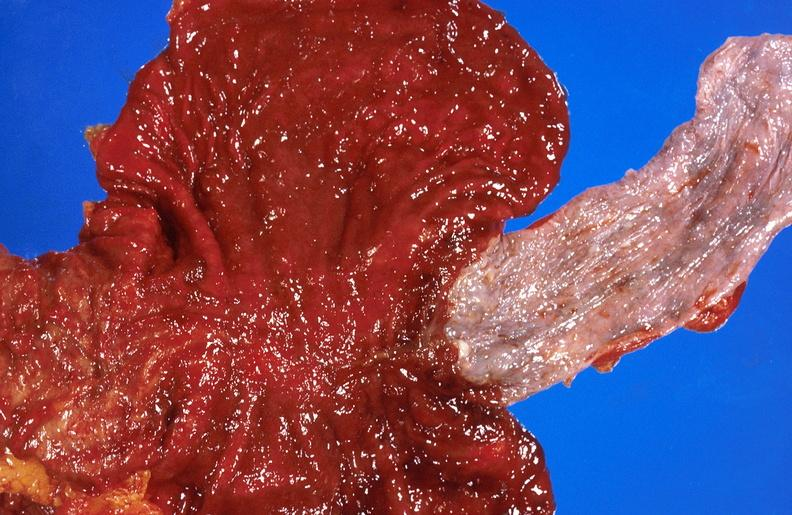what is present?
Answer the question using a single word or phrase. Liver 